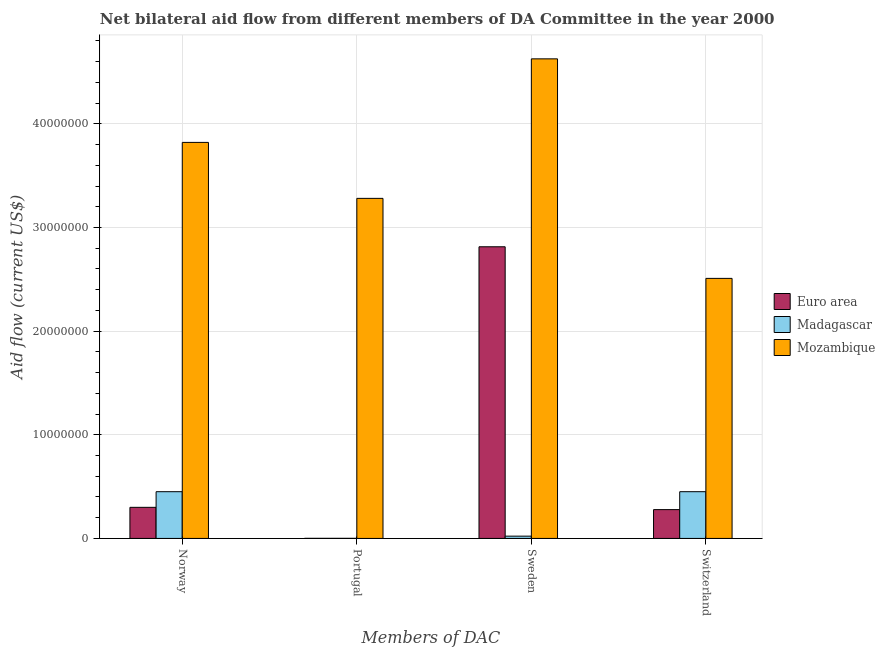How many groups of bars are there?
Keep it short and to the point. 4. Are the number of bars per tick equal to the number of legend labels?
Keep it short and to the point. Yes. How many bars are there on the 3rd tick from the left?
Provide a succinct answer. 3. What is the label of the 4th group of bars from the left?
Provide a succinct answer. Switzerland. What is the amount of aid given by switzerland in Euro area?
Your answer should be compact. 2.78e+06. Across all countries, what is the maximum amount of aid given by sweden?
Your answer should be compact. 4.63e+07. Across all countries, what is the minimum amount of aid given by switzerland?
Provide a succinct answer. 2.78e+06. In which country was the amount of aid given by portugal maximum?
Your answer should be very brief. Mozambique. In which country was the amount of aid given by portugal minimum?
Offer a terse response. Euro area. What is the total amount of aid given by portugal in the graph?
Give a very brief answer. 3.28e+07. What is the difference between the amount of aid given by sweden in Madagascar and that in Euro area?
Your answer should be compact. -2.79e+07. What is the difference between the amount of aid given by switzerland in Euro area and the amount of aid given by portugal in Mozambique?
Offer a very short reply. -3.00e+07. What is the average amount of aid given by norway per country?
Make the answer very short. 1.52e+07. What is the difference between the amount of aid given by switzerland and amount of aid given by sweden in Madagascar?
Provide a short and direct response. 4.29e+06. In how many countries, is the amount of aid given by portugal greater than 24000000 US$?
Your answer should be compact. 1. What is the ratio of the amount of aid given by norway in Euro area to that in Mozambique?
Your answer should be compact. 0.08. What is the difference between the highest and the second highest amount of aid given by sweden?
Provide a succinct answer. 1.81e+07. What is the difference between the highest and the lowest amount of aid given by norway?
Provide a short and direct response. 3.52e+07. Is the sum of the amount of aid given by portugal in Euro area and Mozambique greater than the maximum amount of aid given by sweden across all countries?
Keep it short and to the point. No. Is it the case that in every country, the sum of the amount of aid given by sweden and amount of aid given by switzerland is greater than the sum of amount of aid given by portugal and amount of aid given by norway?
Your answer should be very brief. No. What does the 2nd bar from the right in Norway represents?
Keep it short and to the point. Madagascar. Are all the bars in the graph horizontal?
Your answer should be compact. No. How many countries are there in the graph?
Offer a very short reply. 3. Are the values on the major ticks of Y-axis written in scientific E-notation?
Provide a succinct answer. No. Where does the legend appear in the graph?
Give a very brief answer. Center right. How are the legend labels stacked?
Keep it short and to the point. Vertical. What is the title of the graph?
Provide a succinct answer. Net bilateral aid flow from different members of DA Committee in the year 2000. Does "Other small states" appear as one of the legend labels in the graph?
Offer a very short reply. No. What is the label or title of the X-axis?
Your answer should be compact. Members of DAC. What is the label or title of the Y-axis?
Your answer should be very brief. Aid flow (current US$). What is the Aid flow (current US$) of Euro area in Norway?
Your answer should be very brief. 3.00e+06. What is the Aid flow (current US$) in Madagascar in Norway?
Provide a short and direct response. 4.51e+06. What is the Aid flow (current US$) in Mozambique in Norway?
Your answer should be very brief. 3.82e+07. What is the Aid flow (current US$) in Madagascar in Portugal?
Ensure brevity in your answer.  10000. What is the Aid flow (current US$) in Mozambique in Portugal?
Keep it short and to the point. 3.28e+07. What is the Aid flow (current US$) in Euro area in Sweden?
Your answer should be very brief. 2.81e+07. What is the Aid flow (current US$) of Mozambique in Sweden?
Offer a very short reply. 4.63e+07. What is the Aid flow (current US$) in Euro area in Switzerland?
Make the answer very short. 2.78e+06. What is the Aid flow (current US$) in Madagascar in Switzerland?
Give a very brief answer. 4.51e+06. What is the Aid flow (current US$) in Mozambique in Switzerland?
Provide a succinct answer. 2.51e+07. Across all Members of DAC, what is the maximum Aid flow (current US$) of Euro area?
Keep it short and to the point. 2.81e+07. Across all Members of DAC, what is the maximum Aid flow (current US$) of Madagascar?
Provide a short and direct response. 4.51e+06. Across all Members of DAC, what is the maximum Aid flow (current US$) of Mozambique?
Your answer should be very brief. 4.63e+07. Across all Members of DAC, what is the minimum Aid flow (current US$) of Euro area?
Give a very brief answer. 10000. Across all Members of DAC, what is the minimum Aid flow (current US$) of Mozambique?
Make the answer very short. 2.51e+07. What is the total Aid flow (current US$) in Euro area in the graph?
Make the answer very short. 3.39e+07. What is the total Aid flow (current US$) in Madagascar in the graph?
Ensure brevity in your answer.  9.25e+06. What is the total Aid flow (current US$) of Mozambique in the graph?
Ensure brevity in your answer.  1.42e+08. What is the difference between the Aid flow (current US$) in Euro area in Norway and that in Portugal?
Keep it short and to the point. 2.99e+06. What is the difference between the Aid flow (current US$) in Madagascar in Norway and that in Portugal?
Your answer should be compact. 4.50e+06. What is the difference between the Aid flow (current US$) of Mozambique in Norway and that in Portugal?
Provide a succinct answer. 5.40e+06. What is the difference between the Aid flow (current US$) of Euro area in Norway and that in Sweden?
Give a very brief answer. -2.51e+07. What is the difference between the Aid flow (current US$) in Madagascar in Norway and that in Sweden?
Provide a succinct answer. 4.29e+06. What is the difference between the Aid flow (current US$) in Mozambique in Norway and that in Sweden?
Your response must be concise. -8.06e+06. What is the difference between the Aid flow (current US$) in Madagascar in Norway and that in Switzerland?
Your answer should be compact. 0. What is the difference between the Aid flow (current US$) in Mozambique in Norway and that in Switzerland?
Give a very brief answer. 1.31e+07. What is the difference between the Aid flow (current US$) of Euro area in Portugal and that in Sweden?
Give a very brief answer. -2.81e+07. What is the difference between the Aid flow (current US$) in Madagascar in Portugal and that in Sweden?
Your response must be concise. -2.10e+05. What is the difference between the Aid flow (current US$) in Mozambique in Portugal and that in Sweden?
Ensure brevity in your answer.  -1.35e+07. What is the difference between the Aid flow (current US$) of Euro area in Portugal and that in Switzerland?
Give a very brief answer. -2.77e+06. What is the difference between the Aid flow (current US$) of Madagascar in Portugal and that in Switzerland?
Offer a very short reply. -4.50e+06. What is the difference between the Aid flow (current US$) in Mozambique in Portugal and that in Switzerland?
Offer a terse response. 7.72e+06. What is the difference between the Aid flow (current US$) of Euro area in Sweden and that in Switzerland?
Offer a very short reply. 2.54e+07. What is the difference between the Aid flow (current US$) in Madagascar in Sweden and that in Switzerland?
Offer a very short reply. -4.29e+06. What is the difference between the Aid flow (current US$) of Mozambique in Sweden and that in Switzerland?
Offer a terse response. 2.12e+07. What is the difference between the Aid flow (current US$) in Euro area in Norway and the Aid flow (current US$) in Madagascar in Portugal?
Offer a very short reply. 2.99e+06. What is the difference between the Aid flow (current US$) of Euro area in Norway and the Aid flow (current US$) of Mozambique in Portugal?
Give a very brief answer. -2.98e+07. What is the difference between the Aid flow (current US$) of Madagascar in Norway and the Aid flow (current US$) of Mozambique in Portugal?
Give a very brief answer. -2.83e+07. What is the difference between the Aid flow (current US$) of Euro area in Norway and the Aid flow (current US$) of Madagascar in Sweden?
Your response must be concise. 2.78e+06. What is the difference between the Aid flow (current US$) of Euro area in Norway and the Aid flow (current US$) of Mozambique in Sweden?
Keep it short and to the point. -4.33e+07. What is the difference between the Aid flow (current US$) in Madagascar in Norway and the Aid flow (current US$) in Mozambique in Sweden?
Provide a short and direct response. -4.18e+07. What is the difference between the Aid flow (current US$) in Euro area in Norway and the Aid flow (current US$) in Madagascar in Switzerland?
Provide a succinct answer. -1.51e+06. What is the difference between the Aid flow (current US$) of Euro area in Norway and the Aid flow (current US$) of Mozambique in Switzerland?
Make the answer very short. -2.21e+07. What is the difference between the Aid flow (current US$) of Madagascar in Norway and the Aid flow (current US$) of Mozambique in Switzerland?
Give a very brief answer. -2.06e+07. What is the difference between the Aid flow (current US$) of Euro area in Portugal and the Aid flow (current US$) of Madagascar in Sweden?
Ensure brevity in your answer.  -2.10e+05. What is the difference between the Aid flow (current US$) of Euro area in Portugal and the Aid flow (current US$) of Mozambique in Sweden?
Your answer should be compact. -4.63e+07. What is the difference between the Aid flow (current US$) of Madagascar in Portugal and the Aid flow (current US$) of Mozambique in Sweden?
Keep it short and to the point. -4.63e+07. What is the difference between the Aid flow (current US$) in Euro area in Portugal and the Aid flow (current US$) in Madagascar in Switzerland?
Ensure brevity in your answer.  -4.50e+06. What is the difference between the Aid flow (current US$) of Euro area in Portugal and the Aid flow (current US$) of Mozambique in Switzerland?
Provide a short and direct response. -2.51e+07. What is the difference between the Aid flow (current US$) in Madagascar in Portugal and the Aid flow (current US$) in Mozambique in Switzerland?
Keep it short and to the point. -2.51e+07. What is the difference between the Aid flow (current US$) in Euro area in Sweden and the Aid flow (current US$) in Madagascar in Switzerland?
Your response must be concise. 2.36e+07. What is the difference between the Aid flow (current US$) in Euro area in Sweden and the Aid flow (current US$) in Mozambique in Switzerland?
Your answer should be very brief. 3.05e+06. What is the difference between the Aid flow (current US$) of Madagascar in Sweden and the Aid flow (current US$) of Mozambique in Switzerland?
Provide a succinct answer. -2.49e+07. What is the average Aid flow (current US$) in Euro area per Members of DAC?
Your response must be concise. 8.48e+06. What is the average Aid flow (current US$) in Madagascar per Members of DAC?
Offer a terse response. 2.31e+06. What is the average Aid flow (current US$) in Mozambique per Members of DAC?
Keep it short and to the point. 3.56e+07. What is the difference between the Aid flow (current US$) in Euro area and Aid flow (current US$) in Madagascar in Norway?
Offer a terse response. -1.51e+06. What is the difference between the Aid flow (current US$) of Euro area and Aid flow (current US$) of Mozambique in Norway?
Provide a succinct answer. -3.52e+07. What is the difference between the Aid flow (current US$) in Madagascar and Aid flow (current US$) in Mozambique in Norway?
Keep it short and to the point. -3.37e+07. What is the difference between the Aid flow (current US$) of Euro area and Aid flow (current US$) of Mozambique in Portugal?
Offer a terse response. -3.28e+07. What is the difference between the Aid flow (current US$) of Madagascar and Aid flow (current US$) of Mozambique in Portugal?
Make the answer very short. -3.28e+07. What is the difference between the Aid flow (current US$) of Euro area and Aid flow (current US$) of Madagascar in Sweden?
Provide a succinct answer. 2.79e+07. What is the difference between the Aid flow (current US$) in Euro area and Aid flow (current US$) in Mozambique in Sweden?
Give a very brief answer. -1.81e+07. What is the difference between the Aid flow (current US$) in Madagascar and Aid flow (current US$) in Mozambique in Sweden?
Ensure brevity in your answer.  -4.60e+07. What is the difference between the Aid flow (current US$) in Euro area and Aid flow (current US$) in Madagascar in Switzerland?
Your response must be concise. -1.73e+06. What is the difference between the Aid flow (current US$) of Euro area and Aid flow (current US$) of Mozambique in Switzerland?
Give a very brief answer. -2.23e+07. What is the difference between the Aid flow (current US$) of Madagascar and Aid flow (current US$) of Mozambique in Switzerland?
Offer a very short reply. -2.06e+07. What is the ratio of the Aid flow (current US$) of Euro area in Norway to that in Portugal?
Ensure brevity in your answer.  300. What is the ratio of the Aid flow (current US$) in Madagascar in Norway to that in Portugal?
Offer a terse response. 451. What is the ratio of the Aid flow (current US$) of Mozambique in Norway to that in Portugal?
Offer a very short reply. 1.16. What is the ratio of the Aid flow (current US$) in Euro area in Norway to that in Sweden?
Provide a short and direct response. 0.11. What is the ratio of the Aid flow (current US$) of Mozambique in Norway to that in Sweden?
Ensure brevity in your answer.  0.83. What is the ratio of the Aid flow (current US$) of Euro area in Norway to that in Switzerland?
Give a very brief answer. 1.08. What is the ratio of the Aid flow (current US$) in Madagascar in Norway to that in Switzerland?
Make the answer very short. 1. What is the ratio of the Aid flow (current US$) of Mozambique in Norway to that in Switzerland?
Make the answer very short. 1.52. What is the ratio of the Aid flow (current US$) in Euro area in Portugal to that in Sweden?
Ensure brevity in your answer.  0. What is the ratio of the Aid flow (current US$) of Madagascar in Portugal to that in Sweden?
Provide a succinct answer. 0.05. What is the ratio of the Aid flow (current US$) of Mozambique in Portugal to that in Sweden?
Ensure brevity in your answer.  0.71. What is the ratio of the Aid flow (current US$) in Euro area in Portugal to that in Switzerland?
Make the answer very short. 0. What is the ratio of the Aid flow (current US$) in Madagascar in Portugal to that in Switzerland?
Provide a short and direct response. 0. What is the ratio of the Aid flow (current US$) in Mozambique in Portugal to that in Switzerland?
Your answer should be very brief. 1.31. What is the ratio of the Aid flow (current US$) in Euro area in Sweden to that in Switzerland?
Your response must be concise. 10.12. What is the ratio of the Aid flow (current US$) of Madagascar in Sweden to that in Switzerland?
Your answer should be compact. 0.05. What is the ratio of the Aid flow (current US$) in Mozambique in Sweden to that in Switzerland?
Offer a very short reply. 1.84. What is the difference between the highest and the second highest Aid flow (current US$) of Euro area?
Offer a terse response. 2.51e+07. What is the difference between the highest and the second highest Aid flow (current US$) in Madagascar?
Ensure brevity in your answer.  0. What is the difference between the highest and the second highest Aid flow (current US$) of Mozambique?
Provide a short and direct response. 8.06e+06. What is the difference between the highest and the lowest Aid flow (current US$) of Euro area?
Your response must be concise. 2.81e+07. What is the difference between the highest and the lowest Aid flow (current US$) of Madagascar?
Provide a short and direct response. 4.50e+06. What is the difference between the highest and the lowest Aid flow (current US$) of Mozambique?
Provide a succinct answer. 2.12e+07. 